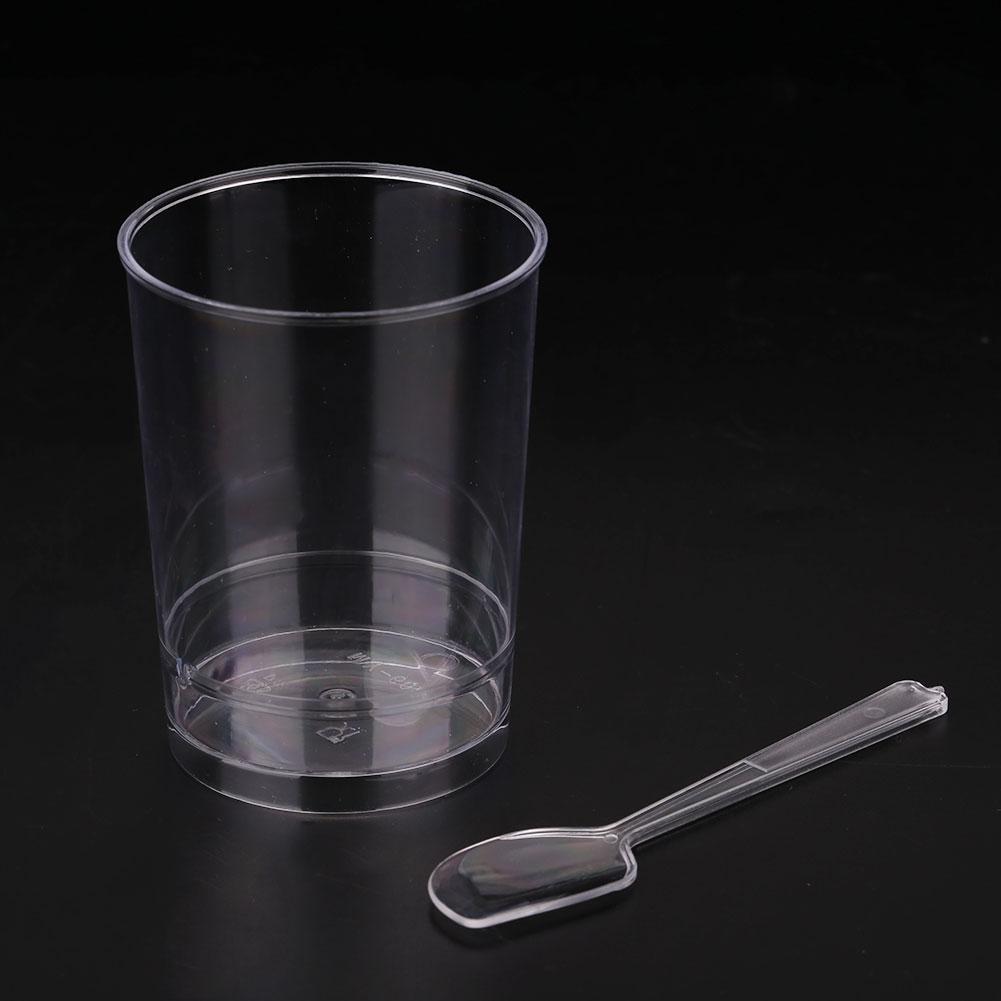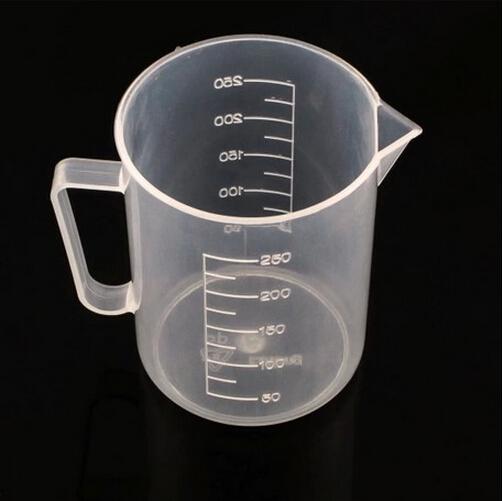The first image is the image on the left, the second image is the image on the right. For the images shown, is this caption "In total, there are two cups and one spoon." true? Answer yes or no. Yes. 